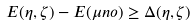Convert formula to latex. <formula><loc_0><loc_0><loc_500><loc_500>E ( \eta , \zeta ) - E ( \mu n o ) \geq \Delta ( \eta , \zeta )</formula> 